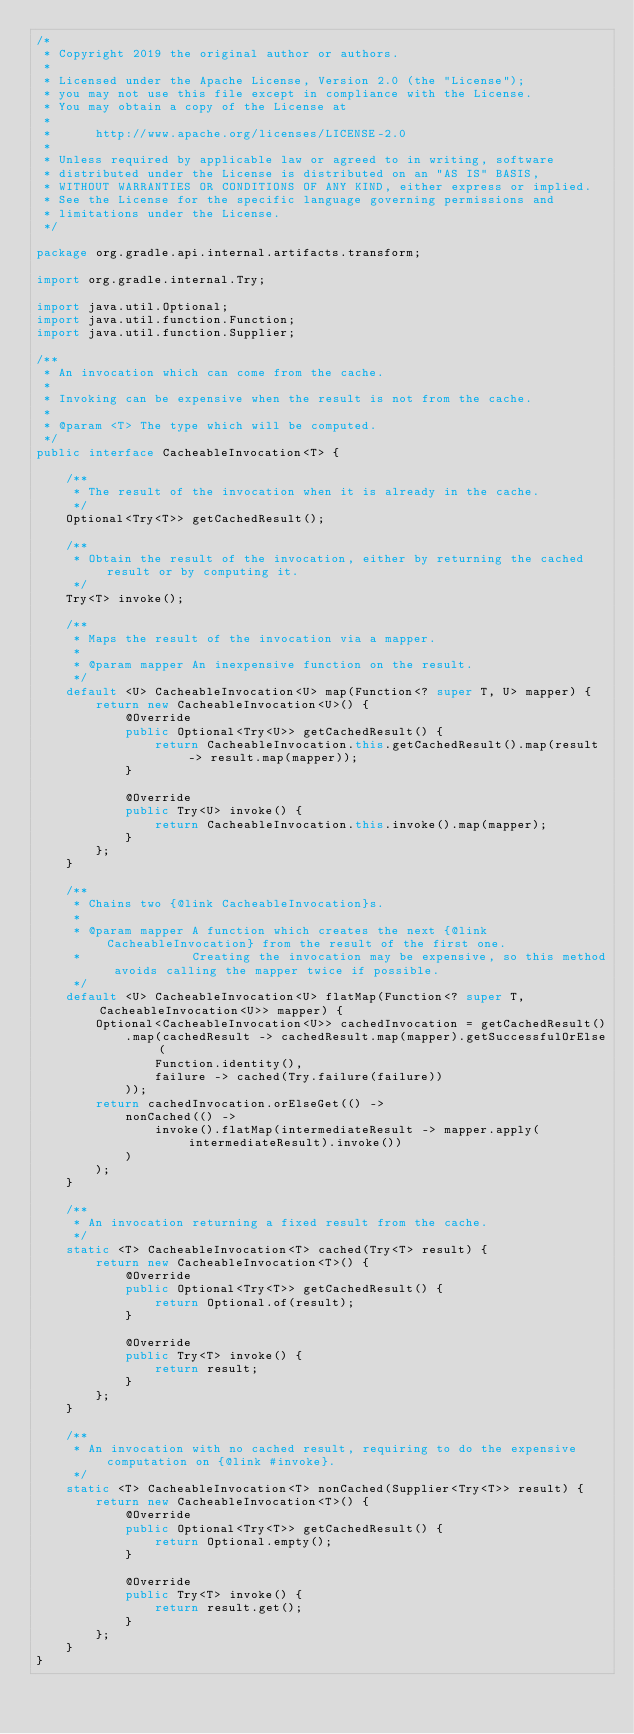Convert code to text. <code><loc_0><loc_0><loc_500><loc_500><_Java_>/*
 * Copyright 2019 the original author or authors.
 *
 * Licensed under the Apache License, Version 2.0 (the "License");
 * you may not use this file except in compliance with the License.
 * You may obtain a copy of the License at
 *
 *      http://www.apache.org/licenses/LICENSE-2.0
 *
 * Unless required by applicable law or agreed to in writing, software
 * distributed under the License is distributed on an "AS IS" BASIS,
 * WITHOUT WARRANTIES OR CONDITIONS OF ANY KIND, either express or implied.
 * See the License for the specific language governing permissions and
 * limitations under the License.
 */

package org.gradle.api.internal.artifacts.transform;

import org.gradle.internal.Try;

import java.util.Optional;
import java.util.function.Function;
import java.util.function.Supplier;

/**
 * An invocation which can come from the cache.
 *
 * Invoking can be expensive when the result is not from the cache.
 *
 * @param <T> The type which will be computed.
 */
public interface CacheableInvocation<T> {

    /**
     * The result of the invocation when it is already in the cache.
     */
    Optional<Try<T>> getCachedResult();

    /**
     * Obtain the result of the invocation, either by returning the cached result or by computing it.
     */
    Try<T> invoke();

    /**
     * Maps the result of the invocation via a mapper.
     *
     * @param mapper An inexpensive function on the result.
     */
    default <U> CacheableInvocation<U> map(Function<? super T, U> mapper) {
        return new CacheableInvocation<U>() {
            @Override
            public Optional<Try<U>> getCachedResult() {
                return CacheableInvocation.this.getCachedResult().map(result -> result.map(mapper));
            }

            @Override
            public Try<U> invoke() {
                return CacheableInvocation.this.invoke().map(mapper);
            }
        };
    }

    /**
     * Chains two {@link CacheableInvocation}s.
     *
     * @param mapper A function which creates the next {@link CacheableInvocation} from the result of the first one.
     *               Creating the invocation may be expensive, so this method avoids calling the mapper twice if possible.
     */
    default <U> CacheableInvocation<U> flatMap(Function<? super T, CacheableInvocation<U>> mapper) {
        Optional<CacheableInvocation<U>> cachedInvocation = getCachedResult()
            .map(cachedResult -> cachedResult.map(mapper).getSuccessfulOrElse(
                Function.identity(),
                failure -> cached(Try.failure(failure))
            ));
        return cachedInvocation.orElseGet(() ->
            nonCached(() ->
                invoke().flatMap(intermediateResult -> mapper.apply(intermediateResult).invoke())
            )
        );
    }

    /**
     * An invocation returning a fixed result from the cache.
     */
    static <T> CacheableInvocation<T> cached(Try<T> result) {
        return new CacheableInvocation<T>() {
            @Override
            public Optional<Try<T>> getCachedResult() {
                return Optional.of(result);
            }

            @Override
            public Try<T> invoke() {
                return result;
            }
        };
    }

    /**
     * An invocation with no cached result, requiring to do the expensive computation on {@link #invoke}.
     */
    static <T> CacheableInvocation<T> nonCached(Supplier<Try<T>> result) {
        return new CacheableInvocation<T>() {
            @Override
            public Optional<Try<T>> getCachedResult() {
                return Optional.empty();
            }

            @Override
            public Try<T> invoke() {
                return result.get();
            }
        };
    }
}
</code> 